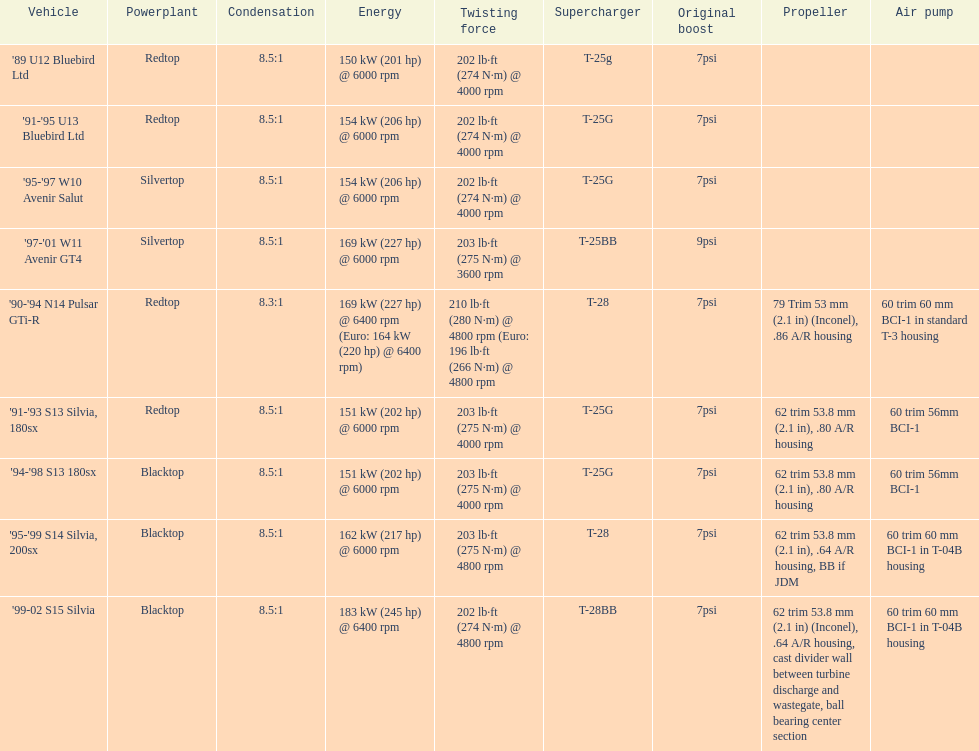Which automobile's strength is assessed above 6000 rpm? '90-'94 N14 Pulsar GTi-R, '99-02 S15 Silvia. 